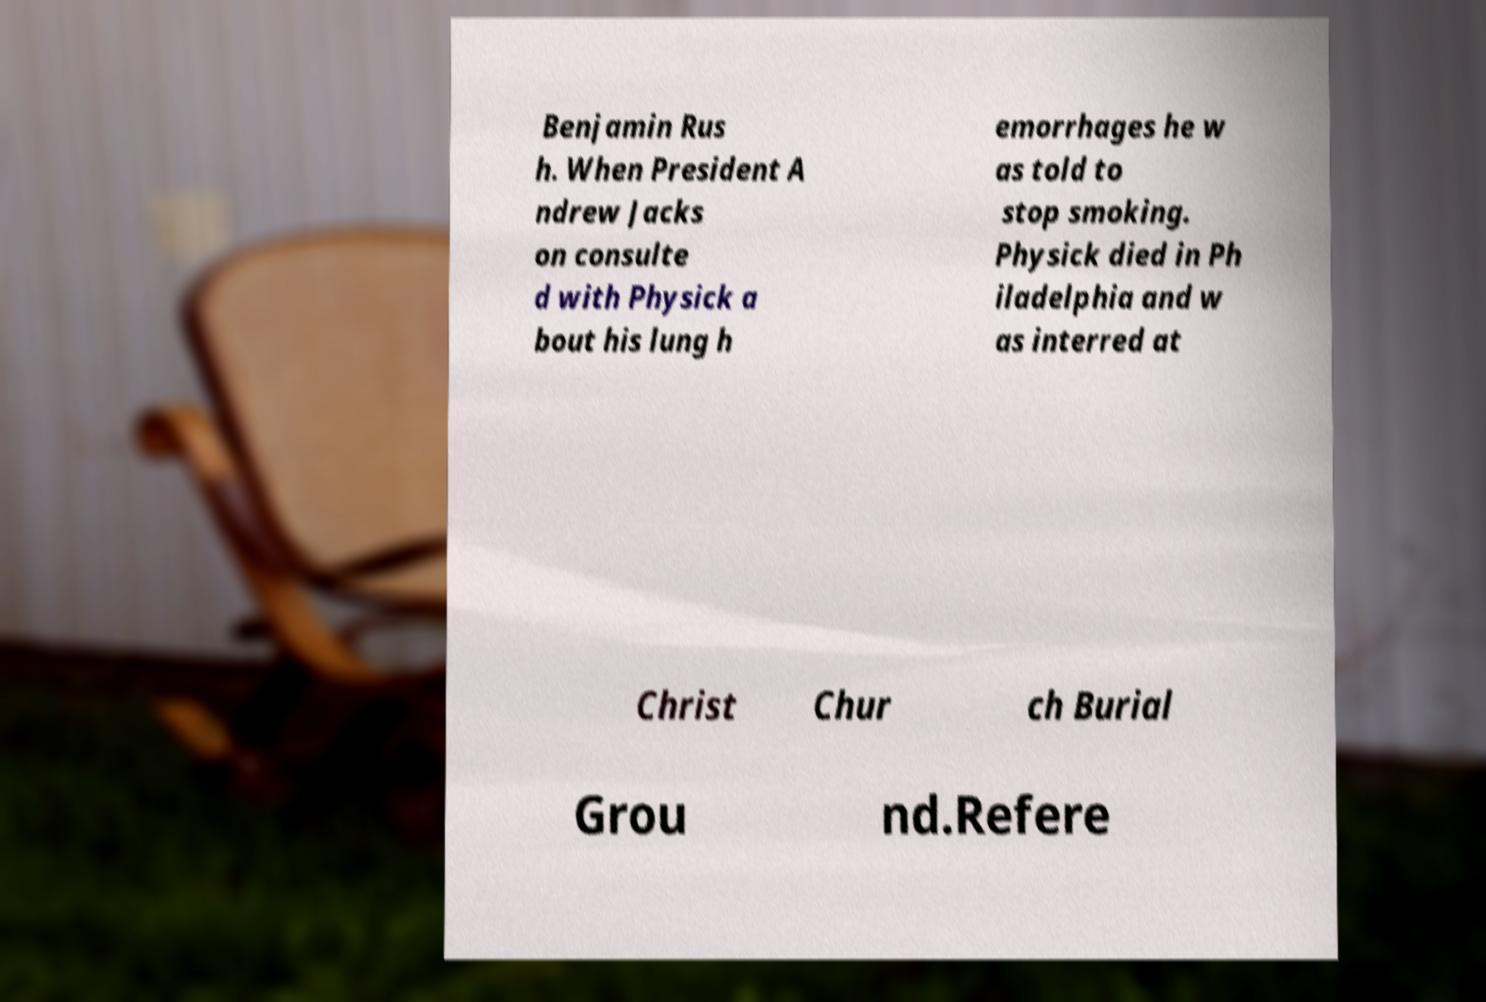What messages or text are displayed in this image? I need them in a readable, typed format. Benjamin Rus h. When President A ndrew Jacks on consulte d with Physick a bout his lung h emorrhages he w as told to stop smoking. Physick died in Ph iladelphia and w as interred at Christ Chur ch Burial Grou nd.Refere 